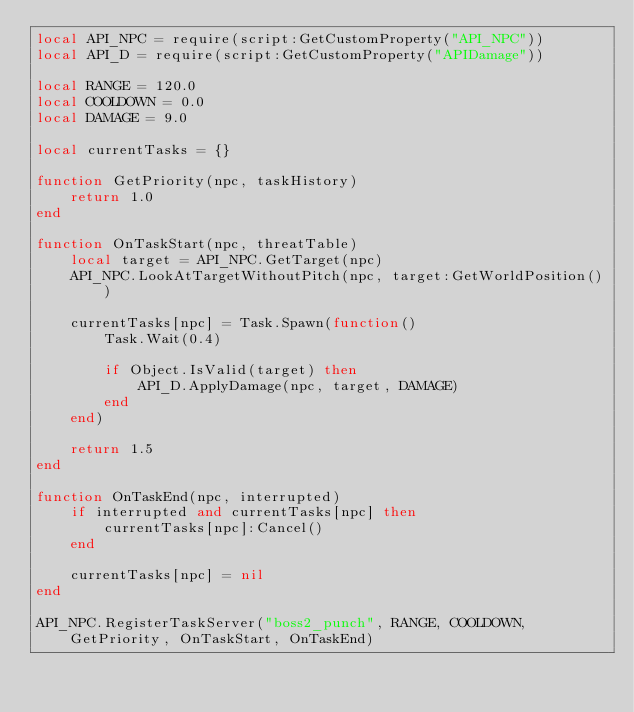Convert code to text. <code><loc_0><loc_0><loc_500><loc_500><_Lua_>local API_NPC = require(script:GetCustomProperty("API_NPC"))
local API_D = require(script:GetCustomProperty("APIDamage"))

local RANGE = 120.0
local COOLDOWN = 0.0
local DAMAGE = 9.0

local currentTasks = {}

function GetPriority(npc, taskHistory)
	return 1.0
end

function OnTaskStart(npc, threatTable)
	local target = API_NPC.GetTarget(npc)
	API_NPC.LookAtTargetWithoutPitch(npc, target:GetWorldPosition())
	
	currentTasks[npc] = Task.Spawn(function()
		Task.Wait(0.4)

		if Object.IsValid(target) then
			API_D.ApplyDamage(npc, target, DAMAGE)
		end
	end)

	return 1.5
end

function OnTaskEnd(npc, interrupted)
	if interrupted and currentTasks[npc] then
		currentTasks[npc]:Cancel()
	end

	currentTasks[npc] = nil
end

API_NPC.RegisterTaskServer("boss2_punch", RANGE, COOLDOWN, GetPriority, OnTaskStart, OnTaskEnd)
</code> 